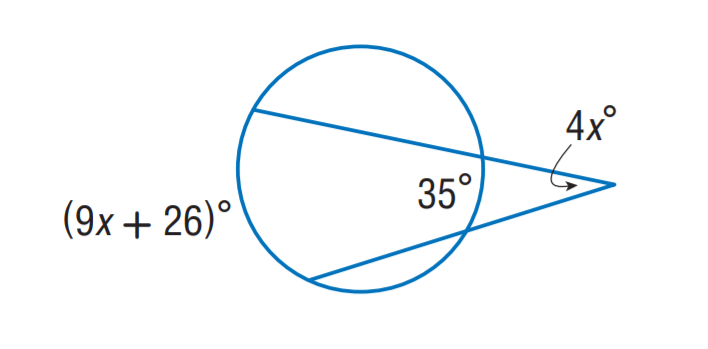Is there a real-world application for understanding angles and tangents? Absolutely, understanding angles and tangents has many real-world applications, such as in engineering to calculate forces and stresses, in architecture to design structures, and even in sports for analyzing trajectories and planning strategies. 